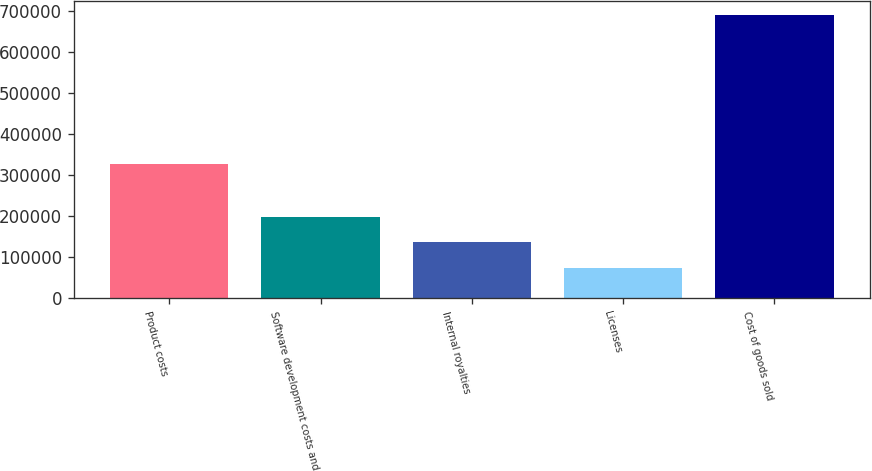Convert chart to OTSL. <chart><loc_0><loc_0><loc_500><loc_500><bar_chart><fcel>Product costs<fcel>Software development costs and<fcel>Internal royalties<fcel>Licenses<fcel>Cost of goods sold<nl><fcel>326936<fcel>197889<fcel>136452<fcel>75016<fcel>689381<nl></chart> 